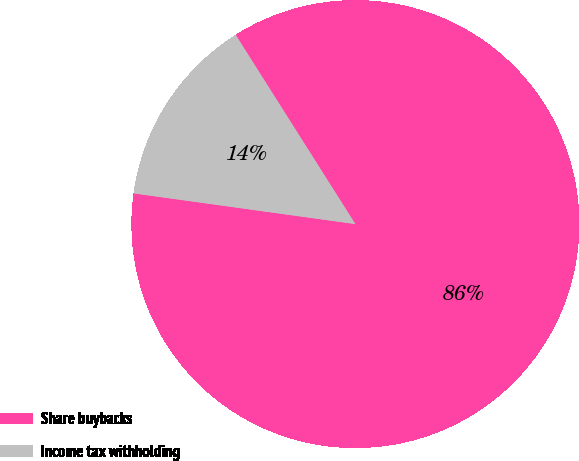Convert chart to OTSL. <chart><loc_0><loc_0><loc_500><loc_500><pie_chart><fcel>Share buybacks<fcel>Income tax withholding<nl><fcel>86.17%<fcel>13.83%<nl></chart> 